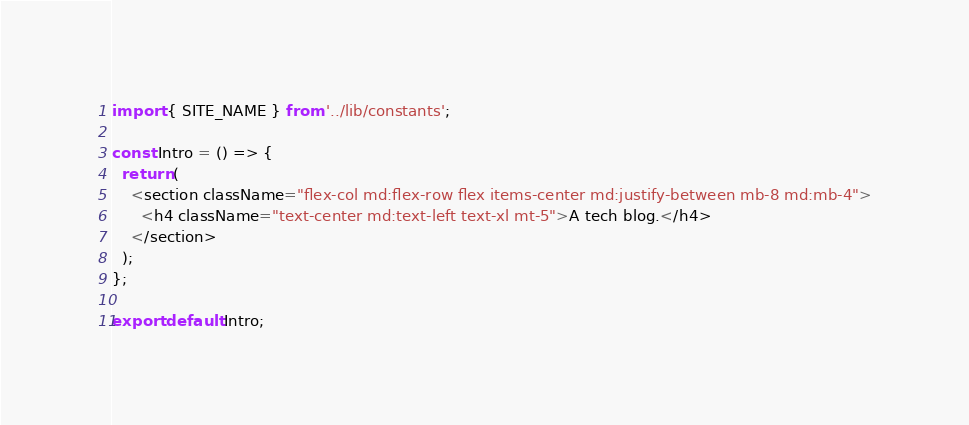<code> <loc_0><loc_0><loc_500><loc_500><_TypeScript_>import { SITE_NAME } from '../lib/constants';

const Intro = () => {
  return (
    <section className="flex-col md:flex-row flex items-center md:justify-between mb-8 md:mb-4">
      <h4 className="text-center md:text-left text-xl mt-5">A tech blog.</h4>
    </section>
  );
};

export default Intro;
</code> 